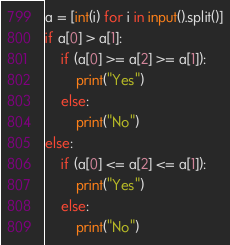Convert code to text. <code><loc_0><loc_0><loc_500><loc_500><_Python_>a = [int(i) for i in input().split()]
if a[0] > a[1]:
    if (a[0] >= a[2] >= a[1]):
        print("Yes")
    else:
        print("No")
else:
    if (a[0] <= a[2] <= a[1]):
        print("Yes")
    else:
        print("No")</code> 